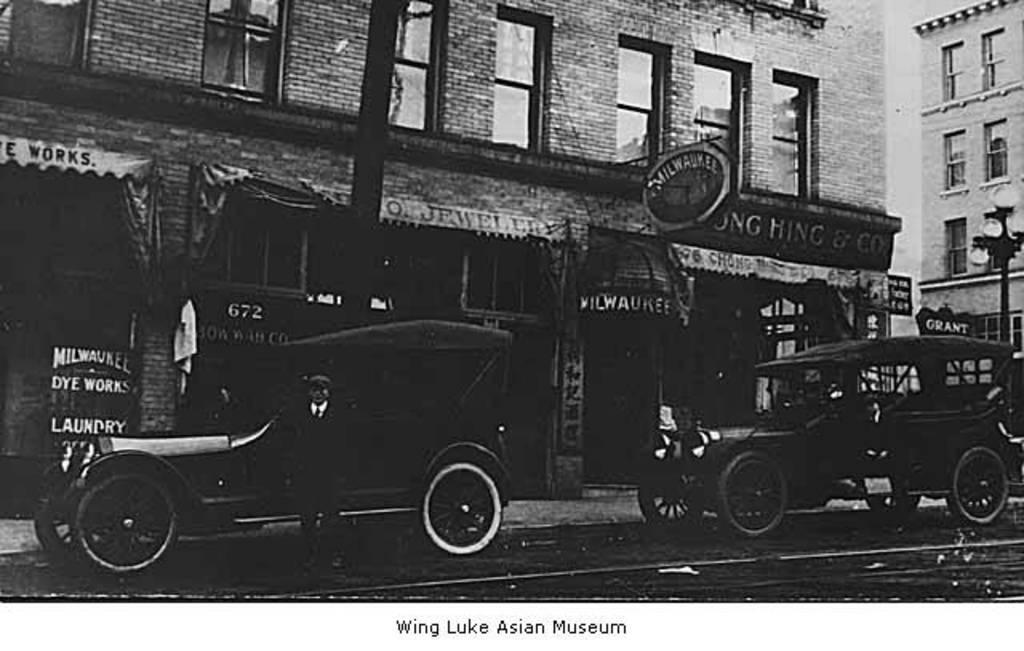Could you give a brief overview of what you see in this image? In this black and white image, there are two cars beside the building. There is a person at the bottom of the image, standing and wearing clothes. There is an another building on the right side of the image. 